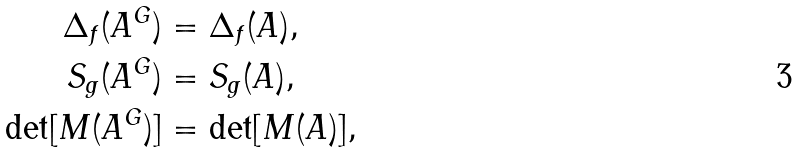Convert formula to latex. <formula><loc_0><loc_0><loc_500><loc_500>\Delta _ { f } ( A ^ { G } ) & = \Delta _ { f } ( A ) , \\ S _ { g } ( A ^ { G } ) & = S _ { g } ( A ) , \\ \det [ M ( A ^ { G } ) ] & = \det [ M ( A ) ] ,</formula> 